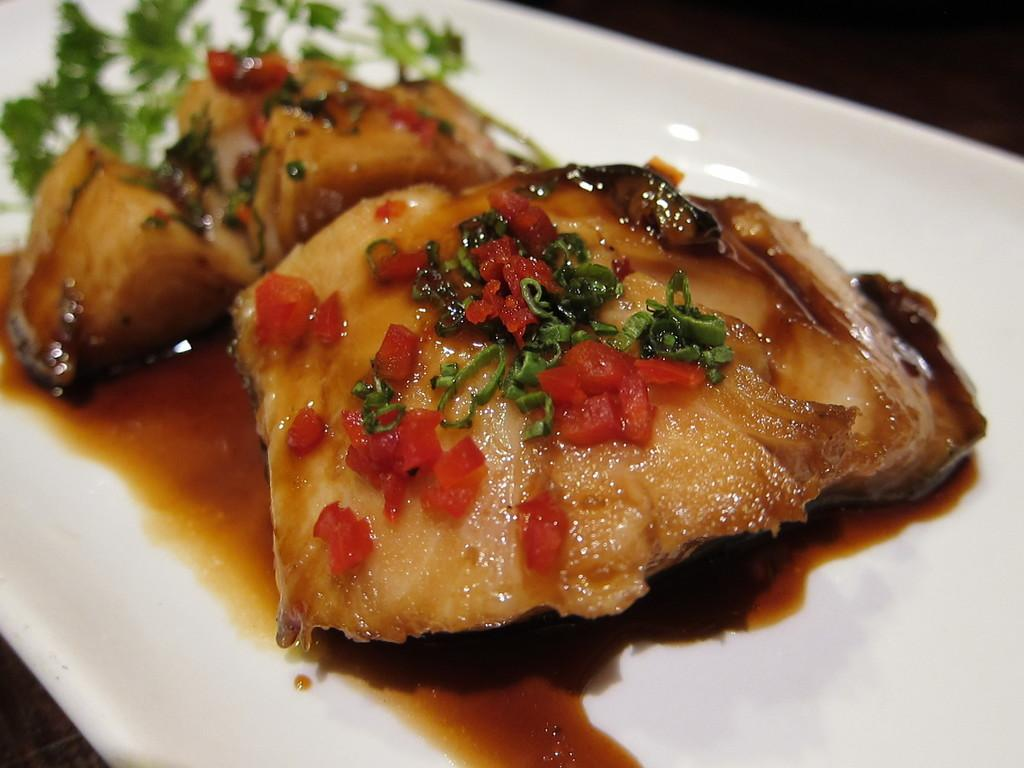What is on the plate in the image? There is cooked bread on the plate. What else is on the plate besides the cooked bread? There is sauce and vegetable garnish on the plate. What type of authority is depicted in the image? There is no authority figure present in the image; it features a plate with cooked bread, sauce, and vegetable garnish. 